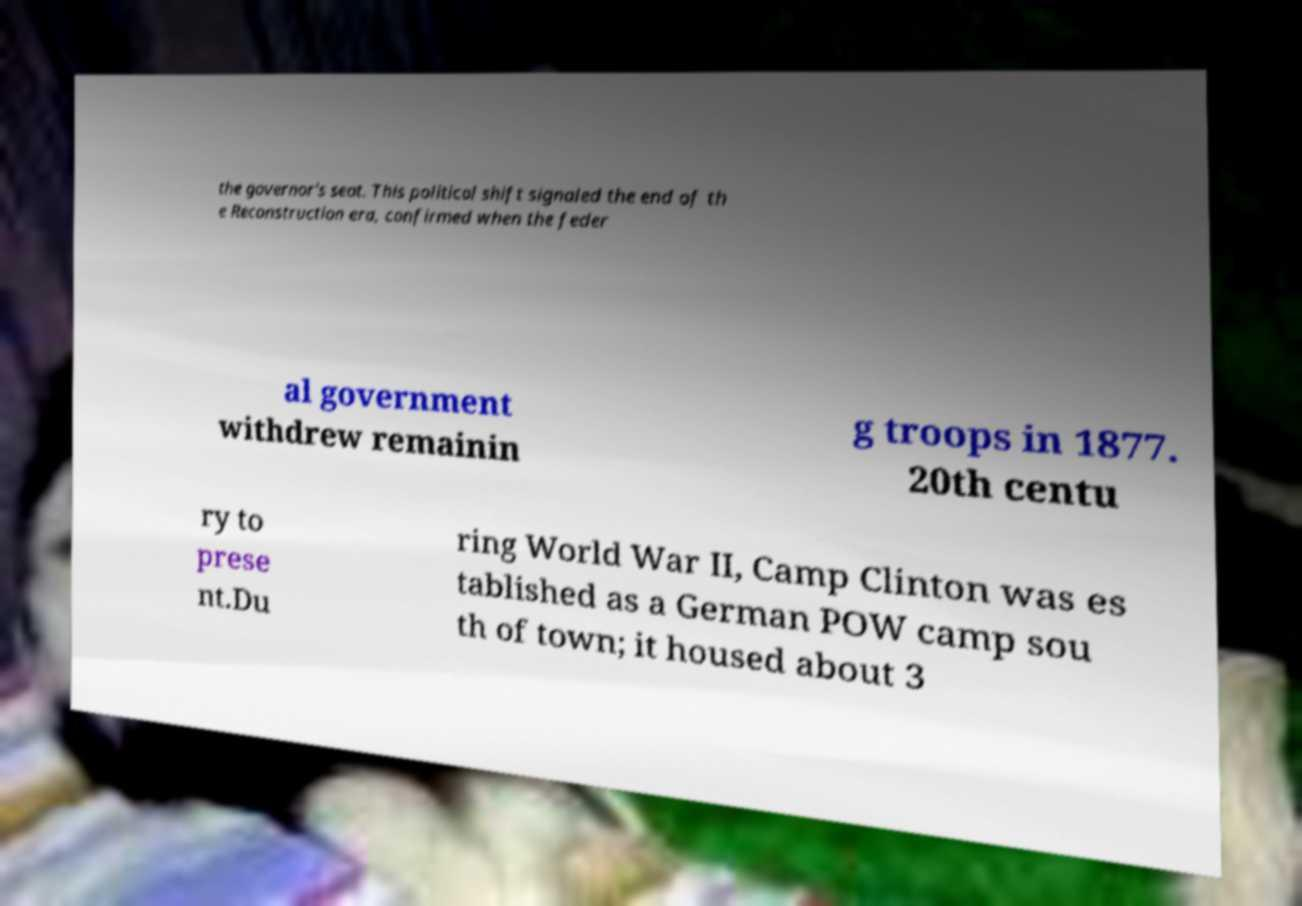Can you read and provide the text displayed in the image?This photo seems to have some interesting text. Can you extract and type it out for me? the governor's seat. This political shift signaled the end of th e Reconstruction era, confirmed when the feder al government withdrew remainin g troops in 1877. 20th centu ry to prese nt.Du ring World War II, Camp Clinton was es tablished as a German POW camp sou th of town; it housed about 3 